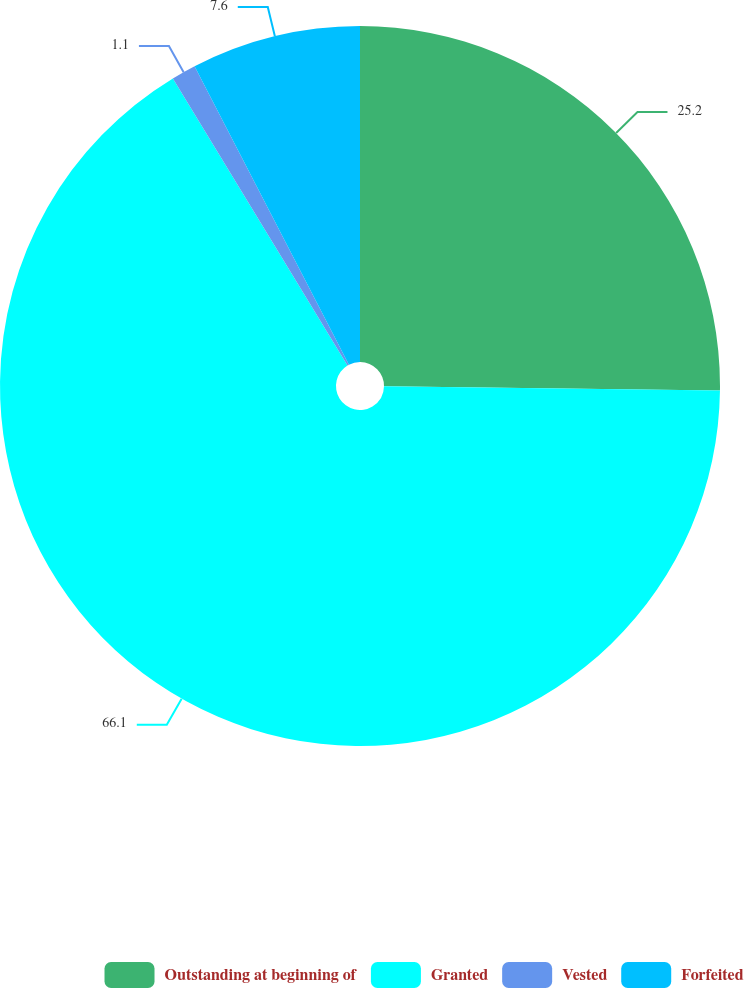Convert chart to OTSL. <chart><loc_0><loc_0><loc_500><loc_500><pie_chart><fcel>Outstanding at beginning of<fcel>Granted<fcel>Vested<fcel>Forfeited<nl><fcel>25.2%<fcel>66.11%<fcel>1.1%<fcel>7.6%<nl></chart> 